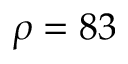Convert formula to latex. <formula><loc_0><loc_0><loc_500><loc_500>\rho = 8 3</formula> 